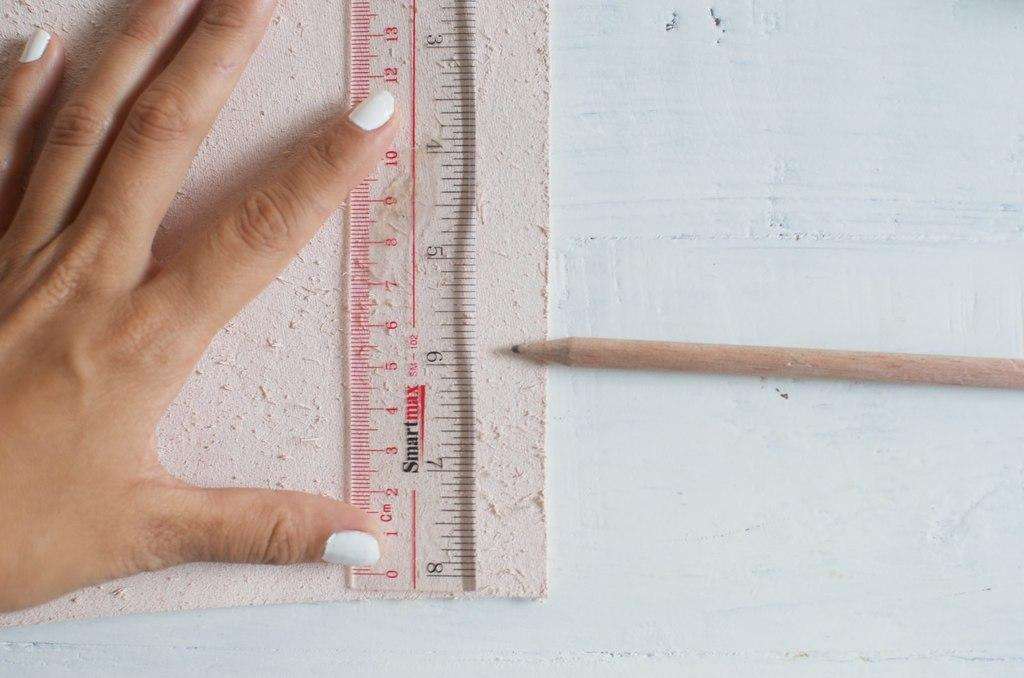<image>
Describe the image concisely. A ruler with a pencil pointing to the 6 inch mark. 